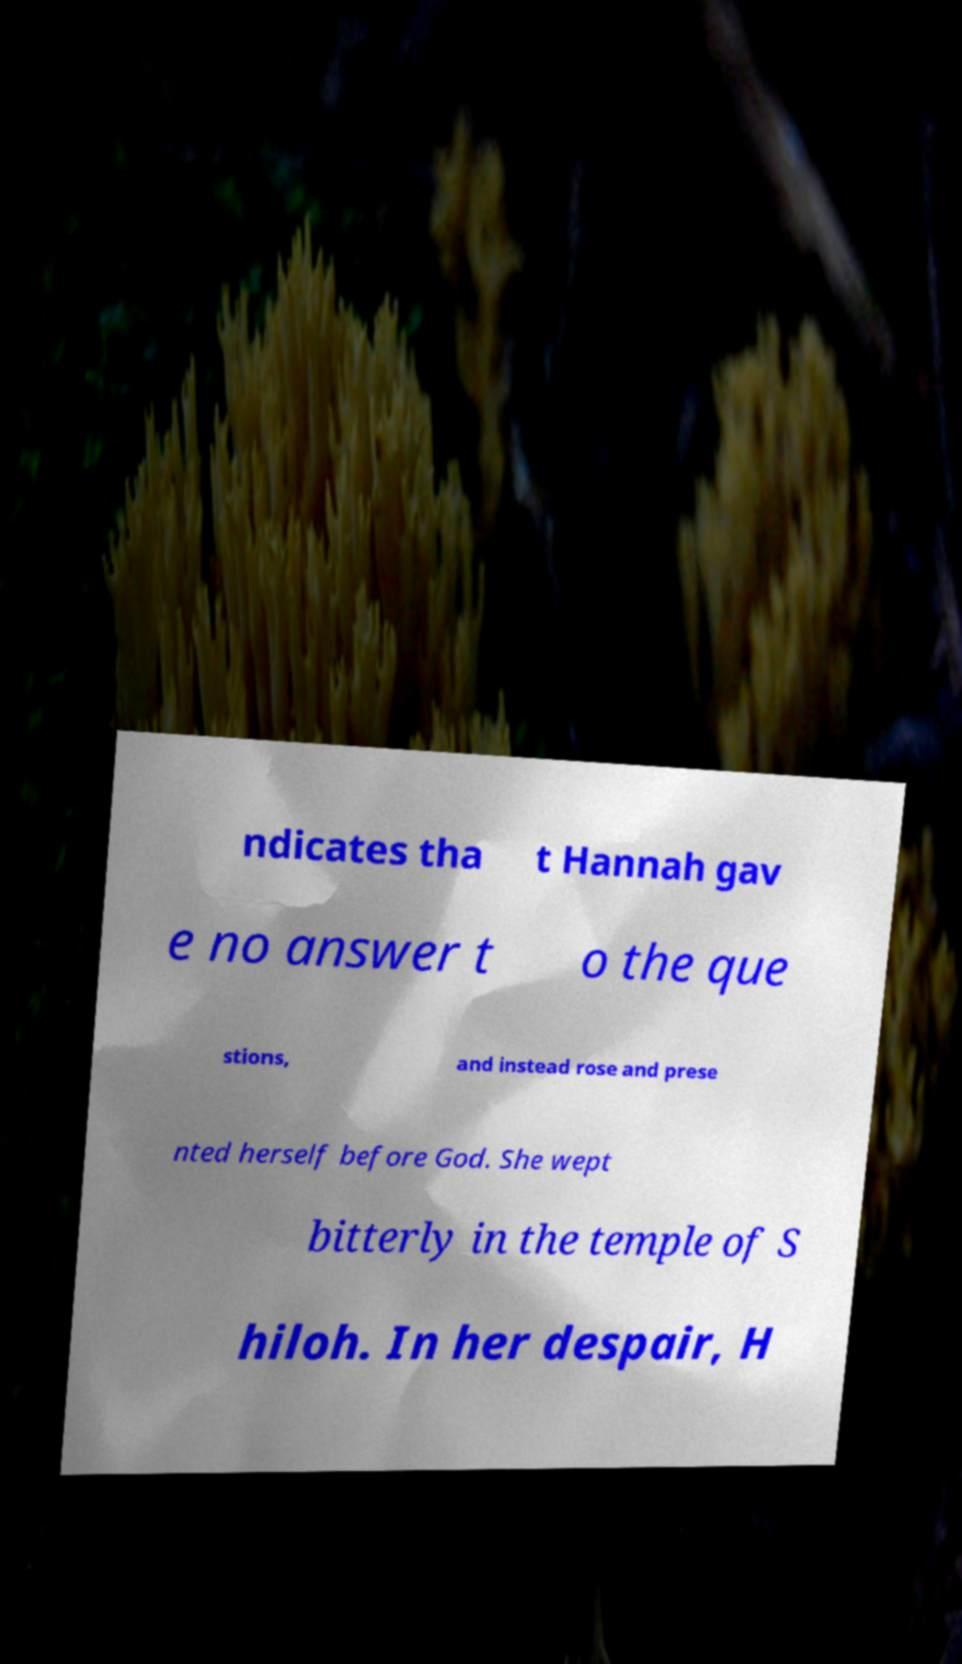Could you assist in decoding the text presented in this image and type it out clearly? ndicates tha t Hannah gav e no answer t o the que stions, and instead rose and prese nted herself before God. She wept bitterly in the temple of S hiloh. In her despair, H 